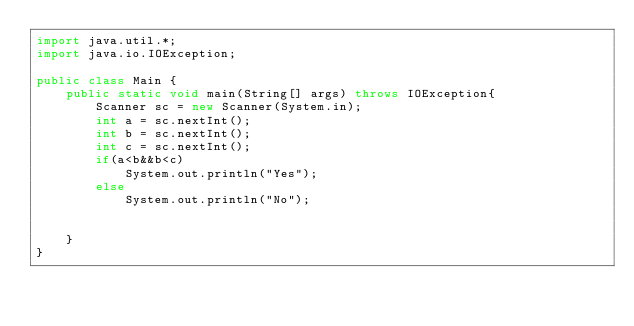<code> <loc_0><loc_0><loc_500><loc_500><_Java_>import java.util.*;
import java.io.IOException;

public class Main {
    public static void main(String[] args) throws IOException{
        Scanner sc = new Scanner(System.in);
        int a = sc.nextInt();
        int b = sc.nextInt();
        int c = sc.nextInt();
        if(a<b&&b<c)
            System.out.println("Yes");
        else
            System.out.println("No");


    }
}</code> 